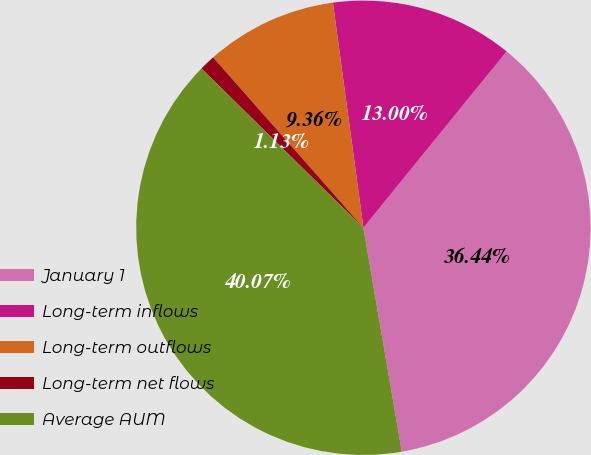Convert chart. <chart><loc_0><loc_0><loc_500><loc_500><pie_chart><fcel>January 1<fcel>Long-term inflows<fcel>Long-term outflows<fcel>Long-term net flows<fcel>Average AUM<nl><fcel>36.44%<fcel>13.0%<fcel>9.36%<fcel>1.13%<fcel>40.07%<nl></chart> 